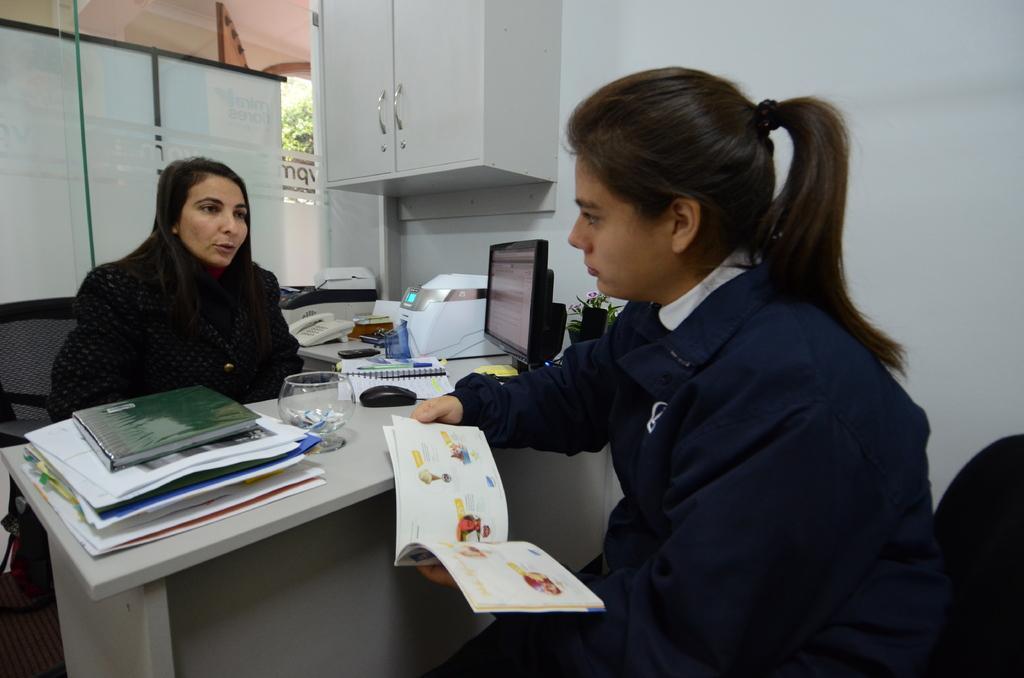Could you give a brief overview of what you see in this image? There are two men in this picture. Both of them are sitting in the chairs on either side of the table on which some books and glass were placed. There is a computer on the table. In the background there is a cupboard and a wall here. 